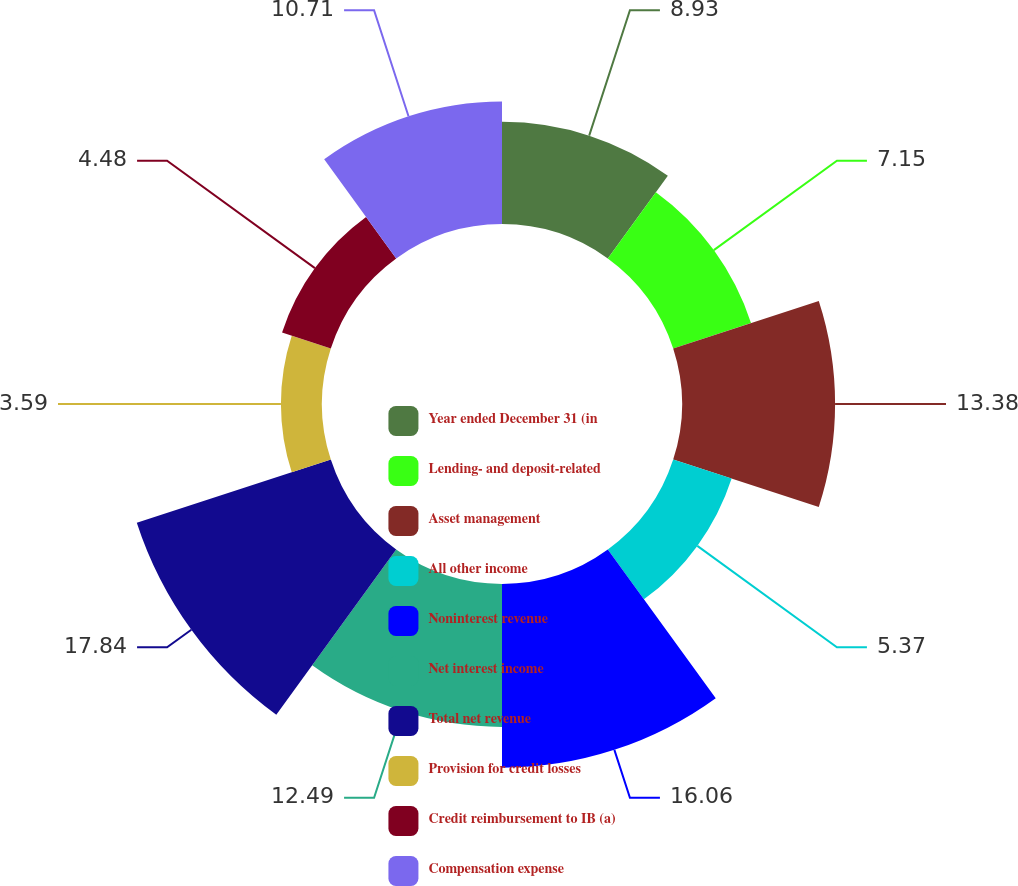<chart> <loc_0><loc_0><loc_500><loc_500><pie_chart><fcel>Year ended December 31 (in<fcel>Lending- and deposit-related<fcel>Asset management<fcel>All other income<fcel>Noninterest revenue<fcel>Net interest income<fcel>Total net revenue<fcel>Provision for credit losses<fcel>Credit reimbursement to IB (a)<fcel>Compensation expense<nl><fcel>8.93%<fcel>7.15%<fcel>13.38%<fcel>5.37%<fcel>16.05%<fcel>12.49%<fcel>17.83%<fcel>3.59%<fcel>4.48%<fcel>10.71%<nl></chart> 